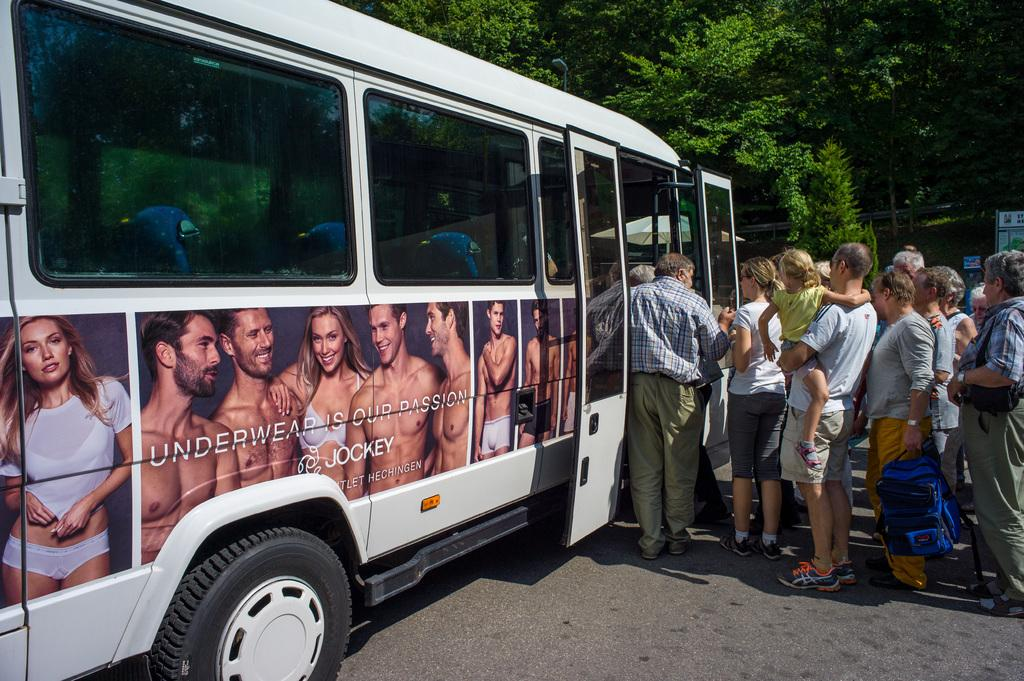<image>
Summarize the visual content of the image. people getting on a white bus that has a jockey underwear ad on it 